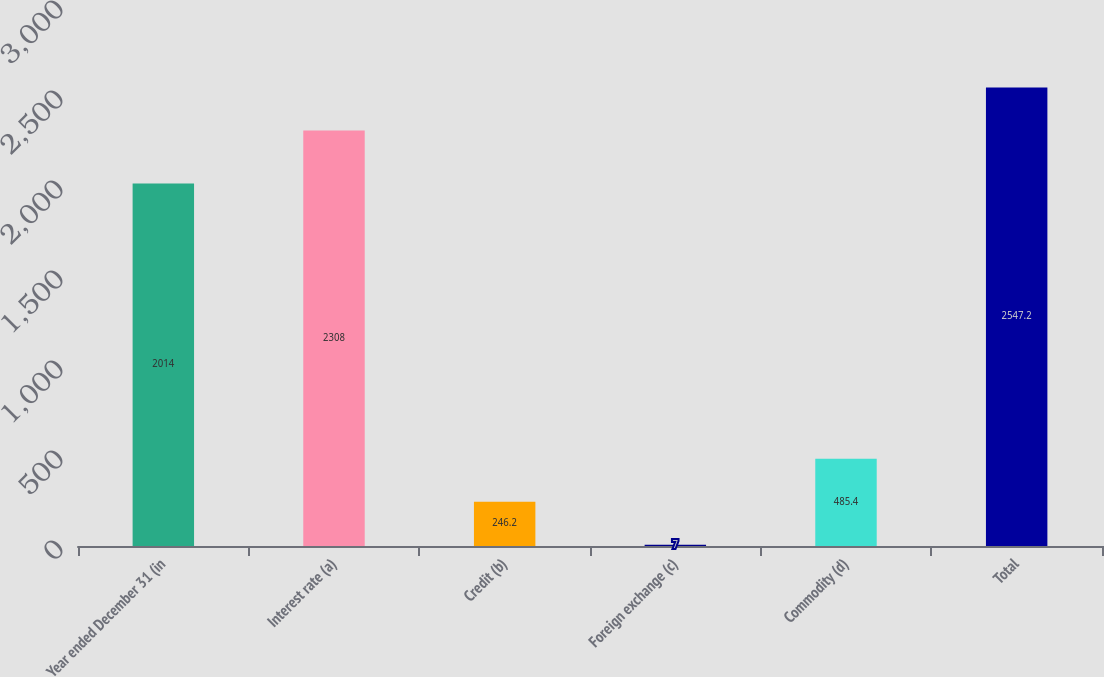<chart> <loc_0><loc_0><loc_500><loc_500><bar_chart><fcel>Year ended December 31 (in<fcel>Interest rate (a)<fcel>Credit (b)<fcel>Foreign exchange (c)<fcel>Commodity (d)<fcel>Total<nl><fcel>2014<fcel>2308<fcel>246.2<fcel>7<fcel>485.4<fcel>2547.2<nl></chart> 